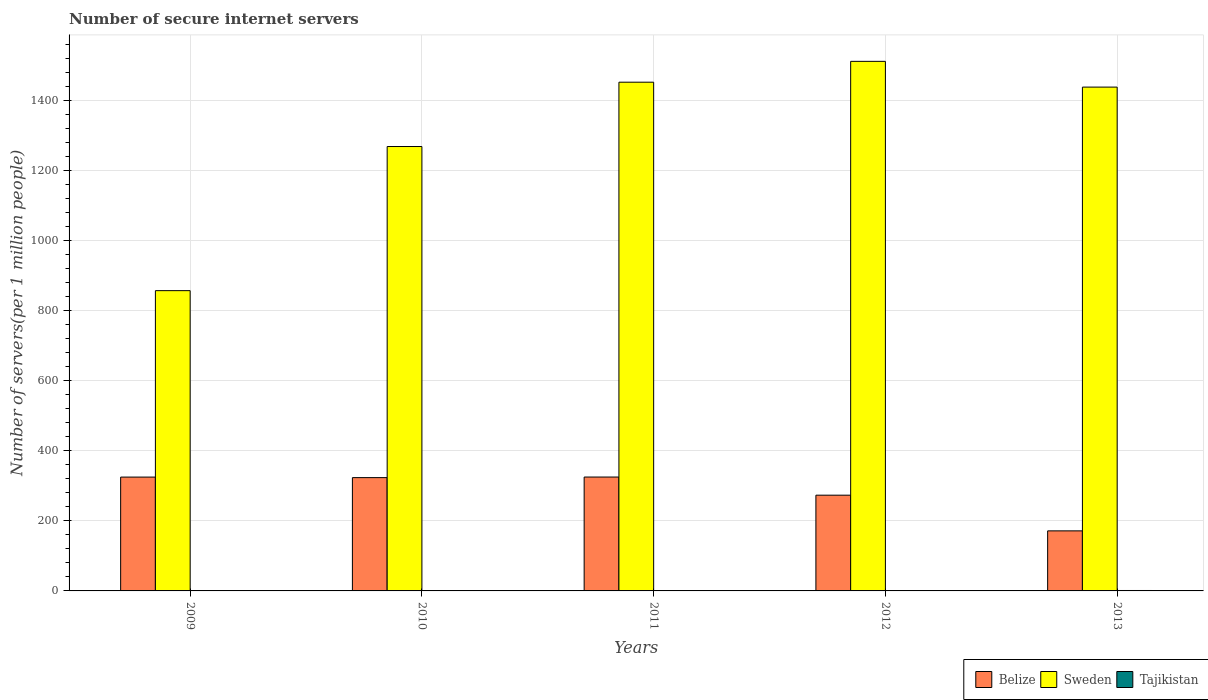How many groups of bars are there?
Offer a terse response. 5. Are the number of bars per tick equal to the number of legend labels?
Ensure brevity in your answer.  Yes. Are the number of bars on each tick of the X-axis equal?
Ensure brevity in your answer.  Yes. How many bars are there on the 1st tick from the left?
Keep it short and to the point. 3. How many bars are there on the 1st tick from the right?
Make the answer very short. 3. What is the label of the 3rd group of bars from the left?
Provide a succinct answer. 2011. What is the number of secure internet servers in Tajikistan in 2013?
Make the answer very short. 1.23. Across all years, what is the maximum number of secure internet servers in Tajikistan?
Offer a very short reply. 1.23. Across all years, what is the minimum number of secure internet servers in Tajikistan?
Make the answer very short. 0.27. In which year was the number of secure internet servers in Belize minimum?
Your answer should be compact. 2013. What is the total number of secure internet servers in Sweden in the graph?
Keep it short and to the point. 6526.78. What is the difference between the number of secure internet servers in Tajikistan in 2009 and that in 2013?
Give a very brief answer. -0.96. What is the difference between the number of secure internet servers in Belize in 2009 and the number of secure internet servers in Sweden in 2013?
Ensure brevity in your answer.  -1113.05. What is the average number of secure internet servers in Belize per year?
Provide a short and direct response. 283.6. In the year 2013, what is the difference between the number of secure internet servers in Belize and number of secure internet servers in Sweden?
Provide a succinct answer. -1266.55. In how many years, is the number of secure internet servers in Sweden greater than 1240?
Provide a succinct answer. 4. What is the ratio of the number of secure internet servers in Belize in 2009 to that in 2010?
Make the answer very short. 1. Is the number of secure internet servers in Belize in 2009 less than that in 2011?
Your response must be concise. Yes. What is the difference between the highest and the second highest number of secure internet servers in Tajikistan?
Keep it short and to the point. 0.35. What is the difference between the highest and the lowest number of secure internet servers in Belize?
Keep it short and to the point. 153.62. Is the sum of the number of secure internet servers in Tajikistan in 2011 and 2012 greater than the maximum number of secure internet servers in Belize across all years?
Your answer should be very brief. No. What does the 3rd bar from the left in 2009 represents?
Make the answer very short. Tajikistan. Is it the case that in every year, the sum of the number of secure internet servers in Tajikistan and number of secure internet servers in Belize is greater than the number of secure internet servers in Sweden?
Your answer should be compact. No. Are all the bars in the graph horizontal?
Provide a succinct answer. No. What is the difference between two consecutive major ticks on the Y-axis?
Give a very brief answer. 200. Does the graph contain any zero values?
Offer a very short reply. No. Does the graph contain grids?
Your response must be concise. Yes. How many legend labels are there?
Ensure brevity in your answer.  3. How are the legend labels stacked?
Your answer should be very brief. Horizontal. What is the title of the graph?
Ensure brevity in your answer.  Number of secure internet servers. What is the label or title of the Y-axis?
Offer a very short reply. Number of servers(per 1 million people). What is the Number of servers(per 1 million people) of Belize in 2009?
Offer a very short reply. 324.92. What is the Number of servers(per 1 million people) in Sweden in 2009?
Your answer should be compact. 857.02. What is the Number of servers(per 1 million people) in Tajikistan in 2009?
Provide a short and direct response. 0.27. What is the Number of servers(per 1 million people) in Belize in 2010?
Provide a succinct answer. 323.37. What is the Number of servers(per 1 million people) in Sweden in 2010?
Provide a short and direct response. 1268.38. What is the Number of servers(per 1 million people) in Tajikistan in 2010?
Make the answer very short. 0.4. What is the Number of servers(per 1 million people) in Belize in 2011?
Your answer should be very brief. 325.04. What is the Number of servers(per 1 million people) of Sweden in 2011?
Your answer should be very brief. 1451.97. What is the Number of servers(per 1 million people) in Tajikistan in 2011?
Give a very brief answer. 0.52. What is the Number of servers(per 1 million people) in Belize in 2012?
Your response must be concise. 273.23. What is the Number of servers(per 1 million people) in Sweden in 2012?
Offer a very short reply. 1511.44. What is the Number of servers(per 1 million people) of Tajikistan in 2012?
Your response must be concise. 0.88. What is the Number of servers(per 1 million people) of Belize in 2013?
Provide a succinct answer. 171.42. What is the Number of servers(per 1 million people) of Sweden in 2013?
Your answer should be very brief. 1437.96. What is the Number of servers(per 1 million people) of Tajikistan in 2013?
Ensure brevity in your answer.  1.23. Across all years, what is the maximum Number of servers(per 1 million people) of Belize?
Provide a succinct answer. 325.04. Across all years, what is the maximum Number of servers(per 1 million people) in Sweden?
Your answer should be very brief. 1511.44. Across all years, what is the maximum Number of servers(per 1 million people) in Tajikistan?
Your answer should be compact. 1.23. Across all years, what is the minimum Number of servers(per 1 million people) of Belize?
Give a very brief answer. 171.42. Across all years, what is the minimum Number of servers(per 1 million people) of Sweden?
Provide a short and direct response. 857.02. Across all years, what is the minimum Number of servers(per 1 million people) of Tajikistan?
Offer a very short reply. 0.27. What is the total Number of servers(per 1 million people) in Belize in the graph?
Give a very brief answer. 1417.98. What is the total Number of servers(per 1 million people) in Sweden in the graph?
Ensure brevity in your answer.  6526.78. What is the total Number of servers(per 1 million people) of Tajikistan in the graph?
Your answer should be compact. 3.3. What is the difference between the Number of servers(per 1 million people) of Belize in 2009 and that in 2010?
Give a very brief answer. 1.54. What is the difference between the Number of servers(per 1 million people) of Sweden in 2009 and that in 2010?
Make the answer very short. -411.36. What is the difference between the Number of servers(per 1 million people) of Tajikistan in 2009 and that in 2010?
Ensure brevity in your answer.  -0.13. What is the difference between the Number of servers(per 1 million people) in Belize in 2009 and that in 2011?
Ensure brevity in your answer.  -0.12. What is the difference between the Number of servers(per 1 million people) in Sweden in 2009 and that in 2011?
Give a very brief answer. -594.95. What is the difference between the Number of servers(per 1 million people) of Tajikistan in 2009 and that in 2011?
Keep it short and to the point. -0.25. What is the difference between the Number of servers(per 1 million people) in Belize in 2009 and that in 2012?
Your response must be concise. 51.68. What is the difference between the Number of servers(per 1 million people) in Sweden in 2009 and that in 2012?
Offer a very short reply. -654.43. What is the difference between the Number of servers(per 1 million people) of Tajikistan in 2009 and that in 2012?
Provide a short and direct response. -0.61. What is the difference between the Number of servers(per 1 million people) of Belize in 2009 and that in 2013?
Give a very brief answer. 153.5. What is the difference between the Number of servers(per 1 million people) of Sweden in 2009 and that in 2013?
Give a very brief answer. -580.95. What is the difference between the Number of servers(per 1 million people) of Tajikistan in 2009 and that in 2013?
Your answer should be very brief. -0.96. What is the difference between the Number of servers(per 1 million people) in Belize in 2010 and that in 2011?
Your answer should be very brief. -1.66. What is the difference between the Number of servers(per 1 million people) in Sweden in 2010 and that in 2011?
Keep it short and to the point. -183.6. What is the difference between the Number of servers(per 1 million people) in Tajikistan in 2010 and that in 2011?
Your answer should be very brief. -0.12. What is the difference between the Number of servers(per 1 million people) in Belize in 2010 and that in 2012?
Offer a very short reply. 50.14. What is the difference between the Number of servers(per 1 million people) of Sweden in 2010 and that in 2012?
Give a very brief answer. -243.07. What is the difference between the Number of servers(per 1 million people) in Tajikistan in 2010 and that in 2012?
Provide a short and direct response. -0.49. What is the difference between the Number of servers(per 1 million people) in Belize in 2010 and that in 2013?
Give a very brief answer. 151.96. What is the difference between the Number of servers(per 1 million people) of Sweden in 2010 and that in 2013?
Give a very brief answer. -169.59. What is the difference between the Number of servers(per 1 million people) in Tajikistan in 2010 and that in 2013?
Your answer should be very brief. -0.84. What is the difference between the Number of servers(per 1 million people) of Belize in 2011 and that in 2012?
Keep it short and to the point. 51.8. What is the difference between the Number of servers(per 1 million people) in Sweden in 2011 and that in 2012?
Provide a succinct answer. -59.47. What is the difference between the Number of servers(per 1 million people) of Tajikistan in 2011 and that in 2012?
Your response must be concise. -0.37. What is the difference between the Number of servers(per 1 million people) of Belize in 2011 and that in 2013?
Ensure brevity in your answer.  153.62. What is the difference between the Number of servers(per 1 million people) in Sweden in 2011 and that in 2013?
Your answer should be compact. 14.01. What is the difference between the Number of servers(per 1 million people) in Tajikistan in 2011 and that in 2013?
Ensure brevity in your answer.  -0.72. What is the difference between the Number of servers(per 1 million people) of Belize in 2012 and that in 2013?
Offer a terse response. 101.82. What is the difference between the Number of servers(per 1 million people) in Sweden in 2012 and that in 2013?
Ensure brevity in your answer.  73.48. What is the difference between the Number of servers(per 1 million people) of Tajikistan in 2012 and that in 2013?
Offer a terse response. -0.35. What is the difference between the Number of servers(per 1 million people) in Belize in 2009 and the Number of servers(per 1 million people) in Sweden in 2010?
Ensure brevity in your answer.  -943.46. What is the difference between the Number of servers(per 1 million people) of Belize in 2009 and the Number of servers(per 1 million people) of Tajikistan in 2010?
Ensure brevity in your answer.  324.52. What is the difference between the Number of servers(per 1 million people) of Sweden in 2009 and the Number of servers(per 1 million people) of Tajikistan in 2010?
Make the answer very short. 856.62. What is the difference between the Number of servers(per 1 million people) in Belize in 2009 and the Number of servers(per 1 million people) in Sweden in 2011?
Give a very brief answer. -1127.05. What is the difference between the Number of servers(per 1 million people) of Belize in 2009 and the Number of servers(per 1 million people) of Tajikistan in 2011?
Offer a terse response. 324.4. What is the difference between the Number of servers(per 1 million people) of Sweden in 2009 and the Number of servers(per 1 million people) of Tajikistan in 2011?
Keep it short and to the point. 856.5. What is the difference between the Number of servers(per 1 million people) in Belize in 2009 and the Number of servers(per 1 million people) in Sweden in 2012?
Provide a succinct answer. -1186.53. What is the difference between the Number of servers(per 1 million people) in Belize in 2009 and the Number of servers(per 1 million people) in Tajikistan in 2012?
Offer a very short reply. 324.04. What is the difference between the Number of servers(per 1 million people) in Sweden in 2009 and the Number of servers(per 1 million people) in Tajikistan in 2012?
Your answer should be very brief. 856.14. What is the difference between the Number of servers(per 1 million people) in Belize in 2009 and the Number of servers(per 1 million people) in Sweden in 2013?
Give a very brief answer. -1113.05. What is the difference between the Number of servers(per 1 million people) of Belize in 2009 and the Number of servers(per 1 million people) of Tajikistan in 2013?
Keep it short and to the point. 323.69. What is the difference between the Number of servers(per 1 million people) of Sweden in 2009 and the Number of servers(per 1 million people) of Tajikistan in 2013?
Your answer should be very brief. 855.79. What is the difference between the Number of servers(per 1 million people) in Belize in 2010 and the Number of servers(per 1 million people) in Sweden in 2011?
Your answer should be compact. -1128.6. What is the difference between the Number of servers(per 1 million people) in Belize in 2010 and the Number of servers(per 1 million people) in Tajikistan in 2011?
Your response must be concise. 322.86. What is the difference between the Number of servers(per 1 million people) of Sweden in 2010 and the Number of servers(per 1 million people) of Tajikistan in 2011?
Keep it short and to the point. 1267.86. What is the difference between the Number of servers(per 1 million people) of Belize in 2010 and the Number of servers(per 1 million people) of Sweden in 2012?
Your answer should be compact. -1188.07. What is the difference between the Number of servers(per 1 million people) in Belize in 2010 and the Number of servers(per 1 million people) in Tajikistan in 2012?
Provide a succinct answer. 322.49. What is the difference between the Number of servers(per 1 million people) of Sweden in 2010 and the Number of servers(per 1 million people) of Tajikistan in 2012?
Your answer should be compact. 1267.49. What is the difference between the Number of servers(per 1 million people) of Belize in 2010 and the Number of servers(per 1 million people) of Sweden in 2013?
Make the answer very short. -1114.59. What is the difference between the Number of servers(per 1 million people) in Belize in 2010 and the Number of servers(per 1 million people) in Tajikistan in 2013?
Keep it short and to the point. 322.14. What is the difference between the Number of servers(per 1 million people) of Sweden in 2010 and the Number of servers(per 1 million people) of Tajikistan in 2013?
Your answer should be compact. 1267.14. What is the difference between the Number of servers(per 1 million people) of Belize in 2011 and the Number of servers(per 1 million people) of Sweden in 2012?
Your response must be concise. -1186.41. What is the difference between the Number of servers(per 1 million people) of Belize in 2011 and the Number of servers(per 1 million people) of Tajikistan in 2012?
Offer a terse response. 324.15. What is the difference between the Number of servers(per 1 million people) in Sweden in 2011 and the Number of servers(per 1 million people) in Tajikistan in 2012?
Offer a terse response. 1451.09. What is the difference between the Number of servers(per 1 million people) in Belize in 2011 and the Number of servers(per 1 million people) in Sweden in 2013?
Your response must be concise. -1112.93. What is the difference between the Number of servers(per 1 million people) of Belize in 2011 and the Number of servers(per 1 million people) of Tajikistan in 2013?
Keep it short and to the point. 323.8. What is the difference between the Number of servers(per 1 million people) in Sweden in 2011 and the Number of servers(per 1 million people) in Tajikistan in 2013?
Your answer should be very brief. 1450.74. What is the difference between the Number of servers(per 1 million people) of Belize in 2012 and the Number of servers(per 1 million people) of Sweden in 2013?
Your response must be concise. -1164.73. What is the difference between the Number of servers(per 1 million people) of Belize in 2012 and the Number of servers(per 1 million people) of Tajikistan in 2013?
Offer a terse response. 272. What is the difference between the Number of servers(per 1 million people) of Sweden in 2012 and the Number of servers(per 1 million people) of Tajikistan in 2013?
Give a very brief answer. 1510.21. What is the average Number of servers(per 1 million people) in Belize per year?
Your answer should be very brief. 283.6. What is the average Number of servers(per 1 million people) in Sweden per year?
Make the answer very short. 1305.36. What is the average Number of servers(per 1 million people) of Tajikistan per year?
Make the answer very short. 0.66. In the year 2009, what is the difference between the Number of servers(per 1 million people) in Belize and Number of servers(per 1 million people) in Sweden?
Offer a terse response. -532.1. In the year 2009, what is the difference between the Number of servers(per 1 million people) of Belize and Number of servers(per 1 million people) of Tajikistan?
Provide a succinct answer. 324.65. In the year 2009, what is the difference between the Number of servers(per 1 million people) in Sweden and Number of servers(per 1 million people) in Tajikistan?
Ensure brevity in your answer.  856.75. In the year 2010, what is the difference between the Number of servers(per 1 million people) in Belize and Number of servers(per 1 million people) in Sweden?
Provide a short and direct response. -945. In the year 2010, what is the difference between the Number of servers(per 1 million people) of Belize and Number of servers(per 1 million people) of Tajikistan?
Provide a succinct answer. 322.98. In the year 2010, what is the difference between the Number of servers(per 1 million people) of Sweden and Number of servers(per 1 million people) of Tajikistan?
Make the answer very short. 1267.98. In the year 2011, what is the difference between the Number of servers(per 1 million people) in Belize and Number of servers(per 1 million people) in Sweden?
Your answer should be very brief. -1126.94. In the year 2011, what is the difference between the Number of servers(per 1 million people) in Belize and Number of servers(per 1 million people) in Tajikistan?
Offer a very short reply. 324.52. In the year 2011, what is the difference between the Number of servers(per 1 million people) of Sweden and Number of servers(per 1 million people) of Tajikistan?
Ensure brevity in your answer.  1451.46. In the year 2012, what is the difference between the Number of servers(per 1 million people) of Belize and Number of servers(per 1 million people) of Sweden?
Give a very brief answer. -1238.21. In the year 2012, what is the difference between the Number of servers(per 1 million people) in Belize and Number of servers(per 1 million people) in Tajikistan?
Give a very brief answer. 272.35. In the year 2012, what is the difference between the Number of servers(per 1 million people) in Sweden and Number of servers(per 1 million people) in Tajikistan?
Your answer should be very brief. 1510.56. In the year 2013, what is the difference between the Number of servers(per 1 million people) of Belize and Number of servers(per 1 million people) of Sweden?
Ensure brevity in your answer.  -1266.55. In the year 2013, what is the difference between the Number of servers(per 1 million people) of Belize and Number of servers(per 1 million people) of Tajikistan?
Your answer should be very brief. 170.18. In the year 2013, what is the difference between the Number of servers(per 1 million people) of Sweden and Number of servers(per 1 million people) of Tajikistan?
Offer a terse response. 1436.73. What is the ratio of the Number of servers(per 1 million people) of Belize in 2009 to that in 2010?
Ensure brevity in your answer.  1. What is the ratio of the Number of servers(per 1 million people) in Sweden in 2009 to that in 2010?
Your answer should be compact. 0.68. What is the ratio of the Number of servers(per 1 million people) of Tajikistan in 2009 to that in 2010?
Keep it short and to the point. 0.68. What is the ratio of the Number of servers(per 1 million people) in Belize in 2009 to that in 2011?
Make the answer very short. 1. What is the ratio of the Number of servers(per 1 million people) in Sweden in 2009 to that in 2011?
Offer a terse response. 0.59. What is the ratio of the Number of servers(per 1 million people) in Tajikistan in 2009 to that in 2011?
Give a very brief answer. 0.52. What is the ratio of the Number of servers(per 1 million people) of Belize in 2009 to that in 2012?
Your answer should be compact. 1.19. What is the ratio of the Number of servers(per 1 million people) of Sweden in 2009 to that in 2012?
Keep it short and to the point. 0.57. What is the ratio of the Number of servers(per 1 million people) in Tajikistan in 2009 to that in 2012?
Make the answer very short. 0.31. What is the ratio of the Number of servers(per 1 million people) of Belize in 2009 to that in 2013?
Ensure brevity in your answer.  1.9. What is the ratio of the Number of servers(per 1 million people) in Sweden in 2009 to that in 2013?
Provide a short and direct response. 0.6. What is the ratio of the Number of servers(per 1 million people) in Tajikistan in 2009 to that in 2013?
Give a very brief answer. 0.22. What is the ratio of the Number of servers(per 1 million people) in Belize in 2010 to that in 2011?
Your response must be concise. 0.99. What is the ratio of the Number of servers(per 1 million people) in Sweden in 2010 to that in 2011?
Your answer should be compact. 0.87. What is the ratio of the Number of servers(per 1 million people) in Tajikistan in 2010 to that in 2011?
Your answer should be very brief. 0.77. What is the ratio of the Number of servers(per 1 million people) of Belize in 2010 to that in 2012?
Provide a succinct answer. 1.18. What is the ratio of the Number of servers(per 1 million people) in Sweden in 2010 to that in 2012?
Your answer should be compact. 0.84. What is the ratio of the Number of servers(per 1 million people) in Tajikistan in 2010 to that in 2012?
Provide a succinct answer. 0.45. What is the ratio of the Number of servers(per 1 million people) of Belize in 2010 to that in 2013?
Give a very brief answer. 1.89. What is the ratio of the Number of servers(per 1 million people) in Sweden in 2010 to that in 2013?
Keep it short and to the point. 0.88. What is the ratio of the Number of servers(per 1 million people) in Tajikistan in 2010 to that in 2013?
Your answer should be very brief. 0.32. What is the ratio of the Number of servers(per 1 million people) in Belize in 2011 to that in 2012?
Your answer should be very brief. 1.19. What is the ratio of the Number of servers(per 1 million people) of Sweden in 2011 to that in 2012?
Offer a terse response. 0.96. What is the ratio of the Number of servers(per 1 million people) in Tajikistan in 2011 to that in 2012?
Your response must be concise. 0.58. What is the ratio of the Number of servers(per 1 million people) of Belize in 2011 to that in 2013?
Give a very brief answer. 1.9. What is the ratio of the Number of servers(per 1 million people) in Sweden in 2011 to that in 2013?
Make the answer very short. 1.01. What is the ratio of the Number of servers(per 1 million people) of Tajikistan in 2011 to that in 2013?
Your answer should be compact. 0.42. What is the ratio of the Number of servers(per 1 million people) in Belize in 2012 to that in 2013?
Ensure brevity in your answer.  1.59. What is the ratio of the Number of servers(per 1 million people) in Sweden in 2012 to that in 2013?
Ensure brevity in your answer.  1.05. What is the ratio of the Number of servers(per 1 million people) of Tajikistan in 2012 to that in 2013?
Provide a short and direct response. 0.72. What is the difference between the highest and the second highest Number of servers(per 1 million people) of Belize?
Keep it short and to the point. 0.12. What is the difference between the highest and the second highest Number of servers(per 1 million people) of Sweden?
Provide a succinct answer. 59.47. What is the difference between the highest and the second highest Number of servers(per 1 million people) in Tajikistan?
Make the answer very short. 0.35. What is the difference between the highest and the lowest Number of servers(per 1 million people) of Belize?
Ensure brevity in your answer.  153.62. What is the difference between the highest and the lowest Number of servers(per 1 million people) of Sweden?
Ensure brevity in your answer.  654.43. 